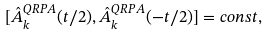Convert formula to latex. <formula><loc_0><loc_0><loc_500><loc_500>[ { \hat { A } } ^ { Q R P A } _ { k } ( t / 2 ) , { \hat { A } } ^ { Q R P A } _ { k } ( - t / 2 ) ] = c o n s t ,</formula> 